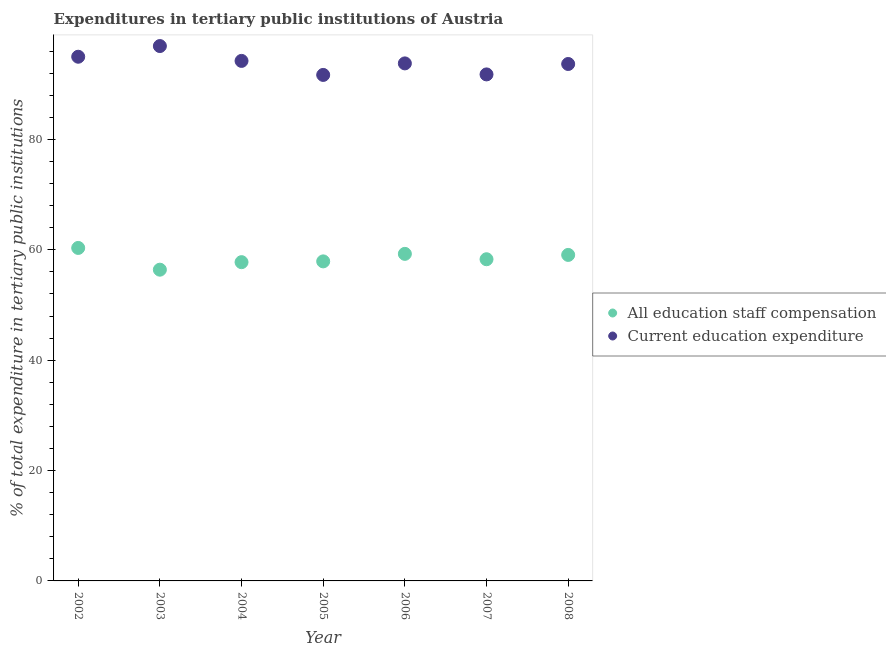Is the number of dotlines equal to the number of legend labels?
Provide a succinct answer. Yes. What is the expenditure in staff compensation in 2006?
Offer a terse response. 59.27. Across all years, what is the maximum expenditure in education?
Keep it short and to the point. 96.93. Across all years, what is the minimum expenditure in education?
Your answer should be compact. 91.69. What is the total expenditure in education in the graph?
Your response must be concise. 657.09. What is the difference between the expenditure in staff compensation in 2003 and that in 2005?
Offer a terse response. -1.51. What is the difference between the expenditure in education in 2007 and the expenditure in staff compensation in 2008?
Your answer should be compact. 32.71. What is the average expenditure in education per year?
Keep it short and to the point. 93.87. In the year 2007, what is the difference between the expenditure in education and expenditure in staff compensation?
Your response must be concise. 33.49. What is the ratio of the expenditure in education in 2002 to that in 2003?
Offer a very short reply. 0.98. What is the difference between the highest and the second highest expenditure in education?
Ensure brevity in your answer.  1.94. What is the difference between the highest and the lowest expenditure in education?
Keep it short and to the point. 5.23. Is the expenditure in education strictly greater than the expenditure in staff compensation over the years?
Your answer should be very brief. Yes. How many years are there in the graph?
Your answer should be compact. 7. What is the difference between two consecutive major ticks on the Y-axis?
Provide a short and direct response. 20. Does the graph contain any zero values?
Give a very brief answer. No. Does the graph contain grids?
Make the answer very short. No. How are the legend labels stacked?
Your answer should be very brief. Vertical. What is the title of the graph?
Provide a short and direct response. Expenditures in tertiary public institutions of Austria. What is the label or title of the Y-axis?
Offer a terse response. % of total expenditure in tertiary public institutions. What is the % of total expenditure in tertiary public institutions of All education staff compensation in 2002?
Provide a short and direct response. 60.34. What is the % of total expenditure in tertiary public institutions of Current education expenditure in 2002?
Offer a terse response. 94.99. What is the % of total expenditure in tertiary public institutions in All education staff compensation in 2003?
Your answer should be very brief. 56.4. What is the % of total expenditure in tertiary public institutions in Current education expenditure in 2003?
Give a very brief answer. 96.93. What is the % of total expenditure in tertiary public institutions in All education staff compensation in 2004?
Your response must be concise. 57.76. What is the % of total expenditure in tertiary public institutions in Current education expenditure in 2004?
Give a very brief answer. 94.23. What is the % of total expenditure in tertiary public institutions of All education staff compensation in 2005?
Make the answer very short. 57.91. What is the % of total expenditure in tertiary public institutions of Current education expenditure in 2005?
Make the answer very short. 91.69. What is the % of total expenditure in tertiary public institutions of All education staff compensation in 2006?
Your answer should be compact. 59.27. What is the % of total expenditure in tertiary public institutions of Current education expenditure in 2006?
Provide a short and direct response. 93.78. What is the % of total expenditure in tertiary public institutions in All education staff compensation in 2007?
Your response must be concise. 58.29. What is the % of total expenditure in tertiary public institutions of Current education expenditure in 2007?
Provide a succinct answer. 91.79. What is the % of total expenditure in tertiary public institutions in All education staff compensation in 2008?
Provide a short and direct response. 59.08. What is the % of total expenditure in tertiary public institutions in Current education expenditure in 2008?
Ensure brevity in your answer.  93.68. Across all years, what is the maximum % of total expenditure in tertiary public institutions in All education staff compensation?
Your answer should be compact. 60.34. Across all years, what is the maximum % of total expenditure in tertiary public institutions of Current education expenditure?
Offer a very short reply. 96.93. Across all years, what is the minimum % of total expenditure in tertiary public institutions of All education staff compensation?
Ensure brevity in your answer.  56.4. Across all years, what is the minimum % of total expenditure in tertiary public institutions of Current education expenditure?
Ensure brevity in your answer.  91.69. What is the total % of total expenditure in tertiary public institutions of All education staff compensation in the graph?
Provide a short and direct response. 409.05. What is the total % of total expenditure in tertiary public institutions of Current education expenditure in the graph?
Give a very brief answer. 657.09. What is the difference between the % of total expenditure in tertiary public institutions in All education staff compensation in 2002 and that in 2003?
Give a very brief answer. 3.94. What is the difference between the % of total expenditure in tertiary public institutions in Current education expenditure in 2002 and that in 2003?
Provide a succinct answer. -1.94. What is the difference between the % of total expenditure in tertiary public institutions in All education staff compensation in 2002 and that in 2004?
Your answer should be compact. 2.58. What is the difference between the % of total expenditure in tertiary public institutions in Current education expenditure in 2002 and that in 2004?
Provide a short and direct response. 0.76. What is the difference between the % of total expenditure in tertiary public institutions in All education staff compensation in 2002 and that in 2005?
Your response must be concise. 2.44. What is the difference between the % of total expenditure in tertiary public institutions in Current education expenditure in 2002 and that in 2005?
Your response must be concise. 3.3. What is the difference between the % of total expenditure in tertiary public institutions in All education staff compensation in 2002 and that in 2006?
Make the answer very short. 1.07. What is the difference between the % of total expenditure in tertiary public institutions in Current education expenditure in 2002 and that in 2006?
Offer a terse response. 1.21. What is the difference between the % of total expenditure in tertiary public institutions in All education staff compensation in 2002 and that in 2007?
Give a very brief answer. 2.05. What is the difference between the % of total expenditure in tertiary public institutions in Current education expenditure in 2002 and that in 2007?
Your answer should be compact. 3.2. What is the difference between the % of total expenditure in tertiary public institutions in All education staff compensation in 2002 and that in 2008?
Provide a succinct answer. 1.27. What is the difference between the % of total expenditure in tertiary public institutions in Current education expenditure in 2002 and that in 2008?
Your response must be concise. 1.31. What is the difference between the % of total expenditure in tertiary public institutions in All education staff compensation in 2003 and that in 2004?
Offer a terse response. -1.36. What is the difference between the % of total expenditure in tertiary public institutions in Current education expenditure in 2003 and that in 2004?
Your answer should be very brief. 2.69. What is the difference between the % of total expenditure in tertiary public institutions of All education staff compensation in 2003 and that in 2005?
Offer a very short reply. -1.51. What is the difference between the % of total expenditure in tertiary public institutions of Current education expenditure in 2003 and that in 2005?
Your answer should be very brief. 5.23. What is the difference between the % of total expenditure in tertiary public institutions of All education staff compensation in 2003 and that in 2006?
Keep it short and to the point. -2.87. What is the difference between the % of total expenditure in tertiary public institutions of Current education expenditure in 2003 and that in 2006?
Your answer should be very brief. 3.14. What is the difference between the % of total expenditure in tertiary public institutions of All education staff compensation in 2003 and that in 2007?
Make the answer very short. -1.89. What is the difference between the % of total expenditure in tertiary public institutions of Current education expenditure in 2003 and that in 2007?
Keep it short and to the point. 5.14. What is the difference between the % of total expenditure in tertiary public institutions of All education staff compensation in 2003 and that in 2008?
Make the answer very short. -2.68. What is the difference between the % of total expenditure in tertiary public institutions in Current education expenditure in 2003 and that in 2008?
Your response must be concise. 3.25. What is the difference between the % of total expenditure in tertiary public institutions in All education staff compensation in 2004 and that in 2005?
Keep it short and to the point. -0.14. What is the difference between the % of total expenditure in tertiary public institutions in Current education expenditure in 2004 and that in 2005?
Provide a short and direct response. 2.54. What is the difference between the % of total expenditure in tertiary public institutions of All education staff compensation in 2004 and that in 2006?
Make the answer very short. -1.5. What is the difference between the % of total expenditure in tertiary public institutions in Current education expenditure in 2004 and that in 2006?
Make the answer very short. 0.45. What is the difference between the % of total expenditure in tertiary public institutions of All education staff compensation in 2004 and that in 2007?
Ensure brevity in your answer.  -0.53. What is the difference between the % of total expenditure in tertiary public institutions in Current education expenditure in 2004 and that in 2007?
Ensure brevity in your answer.  2.45. What is the difference between the % of total expenditure in tertiary public institutions of All education staff compensation in 2004 and that in 2008?
Your response must be concise. -1.31. What is the difference between the % of total expenditure in tertiary public institutions of Current education expenditure in 2004 and that in 2008?
Provide a short and direct response. 0.56. What is the difference between the % of total expenditure in tertiary public institutions in All education staff compensation in 2005 and that in 2006?
Keep it short and to the point. -1.36. What is the difference between the % of total expenditure in tertiary public institutions of Current education expenditure in 2005 and that in 2006?
Your answer should be compact. -2.09. What is the difference between the % of total expenditure in tertiary public institutions in All education staff compensation in 2005 and that in 2007?
Your answer should be compact. -0.39. What is the difference between the % of total expenditure in tertiary public institutions of Current education expenditure in 2005 and that in 2007?
Offer a terse response. -0.09. What is the difference between the % of total expenditure in tertiary public institutions in All education staff compensation in 2005 and that in 2008?
Make the answer very short. -1.17. What is the difference between the % of total expenditure in tertiary public institutions of Current education expenditure in 2005 and that in 2008?
Make the answer very short. -1.98. What is the difference between the % of total expenditure in tertiary public institutions in All education staff compensation in 2006 and that in 2007?
Offer a very short reply. 0.97. What is the difference between the % of total expenditure in tertiary public institutions in Current education expenditure in 2006 and that in 2007?
Your answer should be compact. 2. What is the difference between the % of total expenditure in tertiary public institutions of All education staff compensation in 2006 and that in 2008?
Keep it short and to the point. 0.19. What is the difference between the % of total expenditure in tertiary public institutions in Current education expenditure in 2006 and that in 2008?
Keep it short and to the point. 0.11. What is the difference between the % of total expenditure in tertiary public institutions of All education staff compensation in 2007 and that in 2008?
Offer a very short reply. -0.78. What is the difference between the % of total expenditure in tertiary public institutions of Current education expenditure in 2007 and that in 2008?
Provide a succinct answer. -1.89. What is the difference between the % of total expenditure in tertiary public institutions in All education staff compensation in 2002 and the % of total expenditure in tertiary public institutions in Current education expenditure in 2003?
Your answer should be very brief. -36.58. What is the difference between the % of total expenditure in tertiary public institutions in All education staff compensation in 2002 and the % of total expenditure in tertiary public institutions in Current education expenditure in 2004?
Ensure brevity in your answer.  -33.89. What is the difference between the % of total expenditure in tertiary public institutions in All education staff compensation in 2002 and the % of total expenditure in tertiary public institutions in Current education expenditure in 2005?
Provide a short and direct response. -31.35. What is the difference between the % of total expenditure in tertiary public institutions of All education staff compensation in 2002 and the % of total expenditure in tertiary public institutions of Current education expenditure in 2006?
Your response must be concise. -33.44. What is the difference between the % of total expenditure in tertiary public institutions in All education staff compensation in 2002 and the % of total expenditure in tertiary public institutions in Current education expenditure in 2007?
Offer a terse response. -31.45. What is the difference between the % of total expenditure in tertiary public institutions of All education staff compensation in 2002 and the % of total expenditure in tertiary public institutions of Current education expenditure in 2008?
Give a very brief answer. -33.33. What is the difference between the % of total expenditure in tertiary public institutions of All education staff compensation in 2003 and the % of total expenditure in tertiary public institutions of Current education expenditure in 2004?
Your answer should be very brief. -37.83. What is the difference between the % of total expenditure in tertiary public institutions of All education staff compensation in 2003 and the % of total expenditure in tertiary public institutions of Current education expenditure in 2005?
Provide a succinct answer. -35.29. What is the difference between the % of total expenditure in tertiary public institutions in All education staff compensation in 2003 and the % of total expenditure in tertiary public institutions in Current education expenditure in 2006?
Provide a short and direct response. -37.38. What is the difference between the % of total expenditure in tertiary public institutions in All education staff compensation in 2003 and the % of total expenditure in tertiary public institutions in Current education expenditure in 2007?
Keep it short and to the point. -35.39. What is the difference between the % of total expenditure in tertiary public institutions of All education staff compensation in 2003 and the % of total expenditure in tertiary public institutions of Current education expenditure in 2008?
Provide a succinct answer. -37.27. What is the difference between the % of total expenditure in tertiary public institutions of All education staff compensation in 2004 and the % of total expenditure in tertiary public institutions of Current education expenditure in 2005?
Offer a terse response. -33.93. What is the difference between the % of total expenditure in tertiary public institutions of All education staff compensation in 2004 and the % of total expenditure in tertiary public institutions of Current education expenditure in 2006?
Provide a succinct answer. -36.02. What is the difference between the % of total expenditure in tertiary public institutions of All education staff compensation in 2004 and the % of total expenditure in tertiary public institutions of Current education expenditure in 2007?
Ensure brevity in your answer.  -34.02. What is the difference between the % of total expenditure in tertiary public institutions in All education staff compensation in 2004 and the % of total expenditure in tertiary public institutions in Current education expenditure in 2008?
Your response must be concise. -35.91. What is the difference between the % of total expenditure in tertiary public institutions of All education staff compensation in 2005 and the % of total expenditure in tertiary public institutions of Current education expenditure in 2006?
Ensure brevity in your answer.  -35.88. What is the difference between the % of total expenditure in tertiary public institutions in All education staff compensation in 2005 and the % of total expenditure in tertiary public institutions in Current education expenditure in 2007?
Offer a very short reply. -33.88. What is the difference between the % of total expenditure in tertiary public institutions in All education staff compensation in 2005 and the % of total expenditure in tertiary public institutions in Current education expenditure in 2008?
Provide a short and direct response. -35.77. What is the difference between the % of total expenditure in tertiary public institutions in All education staff compensation in 2006 and the % of total expenditure in tertiary public institutions in Current education expenditure in 2007?
Your answer should be very brief. -32.52. What is the difference between the % of total expenditure in tertiary public institutions in All education staff compensation in 2006 and the % of total expenditure in tertiary public institutions in Current education expenditure in 2008?
Provide a short and direct response. -34.41. What is the difference between the % of total expenditure in tertiary public institutions in All education staff compensation in 2007 and the % of total expenditure in tertiary public institutions in Current education expenditure in 2008?
Make the answer very short. -35.38. What is the average % of total expenditure in tertiary public institutions in All education staff compensation per year?
Your answer should be very brief. 58.44. What is the average % of total expenditure in tertiary public institutions in Current education expenditure per year?
Your response must be concise. 93.87. In the year 2002, what is the difference between the % of total expenditure in tertiary public institutions in All education staff compensation and % of total expenditure in tertiary public institutions in Current education expenditure?
Your answer should be very brief. -34.65. In the year 2003, what is the difference between the % of total expenditure in tertiary public institutions in All education staff compensation and % of total expenditure in tertiary public institutions in Current education expenditure?
Your response must be concise. -40.52. In the year 2004, what is the difference between the % of total expenditure in tertiary public institutions of All education staff compensation and % of total expenditure in tertiary public institutions of Current education expenditure?
Make the answer very short. -36.47. In the year 2005, what is the difference between the % of total expenditure in tertiary public institutions of All education staff compensation and % of total expenditure in tertiary public institutions of Current education expenditure?
Make the answer very short. -33.79. In the year 2006, what is the difference between the % of total expenditure in tertiary public institutions in All education staff compensation and % of total expenditure in tertiary public institutions in Current education expenditure?
Make the answer very short. -34.52. In the year 2007, what is the difference between the % of total expenditure in tertiary public institutions of All education staff compensation and % of total expenditure in tertiary public institutions of Current education expenditure?
Provide a short and direct response. -33.49. In the year 2008, what is the difference between the % of total expenditure in tertiary public institutions in All education staff compensation and % of total expenditure in tertiary public institutions in Current education expenditure?
Offer a very short reply. -34.6. What is the ratio of the % of total expenditure in tertiary public institutions in All education staff compensation in 2002 to that in 2003?
Give a very brief answer. 1.07. What is the ratio of the % of total expenditure in tertiary public institutions in All education staff compensation in 2002 to that in 2004?
Your response must be concise. 1.04. What is the ratio of the % of total expenditure in tertiary public institutions in All education staff compensation in 2002 to that in 2005?
Your answer should be very brief. 1.04. What is the ratio of the % of total expenditure in tertiary public institutions of Current education expenditure in 2002 to that in 2005?
Offer a very short reply. 1.04. What is the ratio of the % of total expenditure in tertiary public institutions of All education staff compensation in 2002 to that in 2006?
Provide a succinct answer. 1.02. What is the ratio of the % of total expenditure in tertiary public institutions in Current education expenditure in 2002 to that in 2006?
Keep it short and to the point. 1.01. What is the ratio of the % of total expenditure in tertiary public institutions in All education staff compensation in 2002 to that in 2007?
Your answer should be compact. 1.04. What is the ratio of the % of total expenditure in tertiary public institutions of Current education expenditure in 2002 to that in 2007?
Provide a short and direct response. 1.03. What is the ratio of the % of total expenditure in tertiary public institutions of All education staff compensation in 2002 to that in 2008?
Your response must be concise. 1.02. What is the ratio of the % of total expenditure in tertiary public institutions of All education staff compensation in 2003 to that in 2004?
Keep it short and to the point. 0.98. What is the ratio of the % of total expenditure in tertiary public institutions of Current education expenditure in 2003 to that in 2004?
Offer a terse response. 1.03. What is the ratio of the % of total expenditure in tertiary public institutions of Current education expenditure in 2003 to that in 2005?
Provide a short and direct response. 1.06. What is the ratio of the % of total expenditure in tertiary public institutions of All education staff compensation in 2003 to that in 2006?
Offer a very short reply. 0.95. What is the ratio of the % of total expenditure in tertiary public institutions of Current education expenditure in 2003 to that in 2006?
Make the answer very short. 1.03. What is the ratio of the % of total expenditure in tertiary public institutions of All education staff compensation in 2003 to that in 2007?
Provide a short and direct response. 0.97. What is the ratio of the % of total expenditure in tertiary public institutions of Current education expenditure in 2003 to that in 2007?
Your answer should be compact. 1.06. What is the ratio of the % of total expenditure in tertiary public institutions in All education staff compensation in 2003 to that in 2008?
Give a very brief answer. 0.95. What is the ratio of the % of total expenditure in tertiary public institutions of Current education expenditure in 2003 to that in 2008?
Give a very brief answer. 1.03. What is the ratio of the % of total expenditure in tertiary public institutions of Current education expenditure in 2004 to that in 2005?
Make the answer very short. 1.03. What is the ratio of the % of total expenditure in tertiary public institutions of All education staff compensation in 2004 to that in 2006?
Offer a terse response. 0.97. What is the ratio of the % of total expenditure in tertiary public institutions in All education staff compensation in 2004 to that in 2007?
Ensure brevity in your answer.  0.99. What is the ratio of the % of total expenditure in tertiary public institutions in Current education expenditure in 2004 to that in 2007?
Provide a succinct answer. 1.03. What is the ratio of the % of total expenditure in tertiary public institutions in All education staff compensation in 2004 to that in 2008?
Make the answer very short. 0.98. What is the ratio of the % of total expenditure in tertiary public institutions in All education staff compensation in 2005 to that in 2006?
Give a very brief answer. 0.98. What is the ratio of the % of total expenditure in tertiary public institutions in Current education expenditure in 2005 to that in 2006?
Provide a short and direct response. 0.98. What is the ratio of the % of total expenditure in tertiary public institutions in All education staff compensation in 2005 to that in 2007?
Give a very brief answer. 0.99. What is the ratio of the % of total expenditure in tertiary public institutions in Current education expenditure in 2005 to that in 2007?
Your answer should be compact. 1. What is the ratio of the % of total expenditure in tertiary public institutions of All education staff compensation in 2005 to that in 2008?
Keep it short and to the point. 0.98. What is the ratio of the % of total expenditure in tertiary public institutions of Current education expenditure in 2005 to that in 2008?
Your answer should be compact. 0.98. What is the ratio of the % of total expenditure in tertiary public institutions in All education staff compensation in 2006 to that in 2007?
Keep it short and to the point. 1.02. What is the ratio of the % of total expenditure in tertiary public institutions of Current education expenditure in 2006 to that in 2007?
Make the answer very short. 1.02. What is the ratio of the % of total expenditure in tertiary public institutions of Current education expenditure in 2006 to that in 2008?
Provide a short and direct response. 1. What is the ratio of the % of total expenditure in tertiary public institutions in All education staff compensation in 2007 to that in 2008?
Your answer should be very brief. 0.99. What is the ratio of the % of total expenditure in tertiary public institutions in Current education expenditure in 2007 to that in 2008?
Make the answer very short. 0.98. What is the difference between the highest and the second highest % of total expenditure in tertiary public institutions of All education staff compensation?
Your answer should be compact. 1.07. What is the difference between the highest and the second highest % of total expenditure in tertiary public institutions of Current education expenditure?
Provide a short and direct response. 1.94. What is the difference between the highest and the lowest % of total expenditure in tertiary public institutions in All education staff compensation?
Make the answer very short. 3.94. What is the difference between the highest and the lowest % of total expenditure in tertiary public institutions in Current education expenditure?
Your answer should be compact. 5.23. 